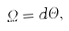<formula> <loc_0><loc_0><loc_500><loc_500>\Omega = d \Theta ,</formula> 